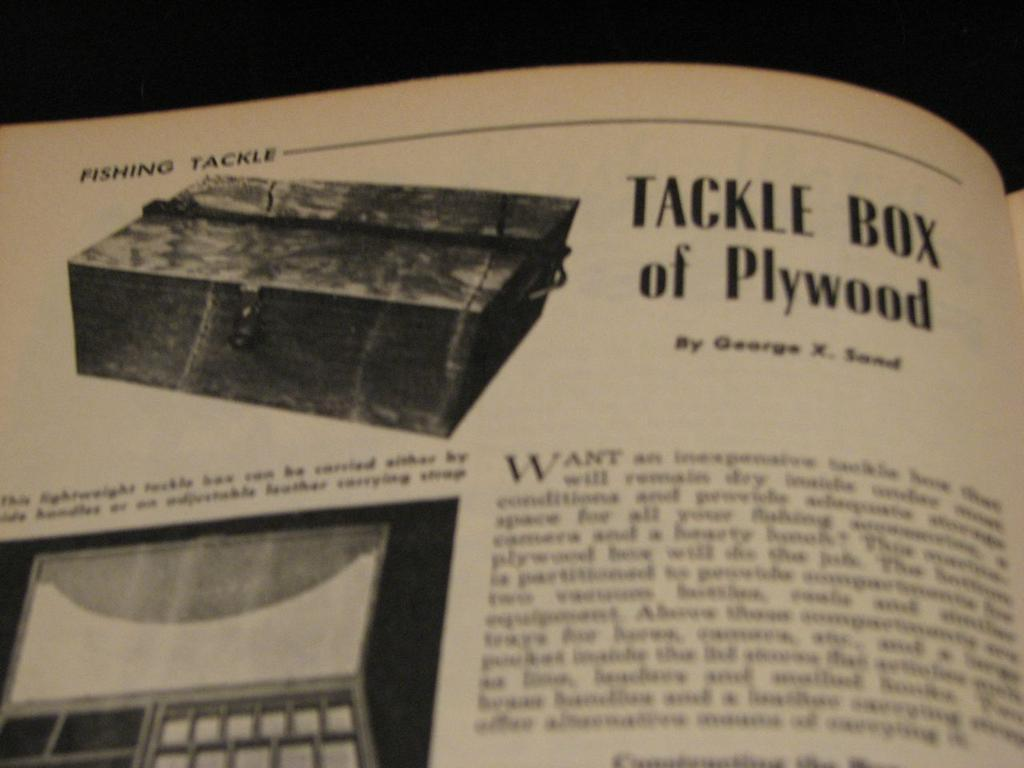<image>
Relay a brief, clear account of the picture shown. A magazine featuring a photo of a tackle box of plywood. 